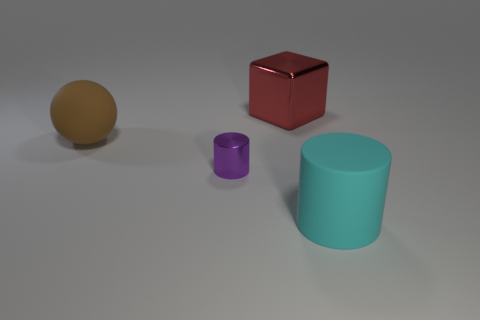Is there any other thing that is made of the same material as the block?
Your answer should be compact. Yes. What is the size of the rubber object that is to the left of the large rubber object in front of the big brown ball?
Provide a succinct answer. Large. Is the number of purple objects that are to the right of the cyan rubber cylinder the same as the number of tiny gray metal cylinders?
Make the answer very short. Yes. How many other things are the same color as the matte cylinder?
Your answer should be very brief. 0. Are there fewer big shiny cubes in front of the cube than cyan matte cylinders?
Make the answer very short. Yes. Are there any things that have the same size as the red shiny block?
Your answer should be compact. Yes. There is a big metal object; is its color the same as the large thing right of the red cube?
Ensure brevity in your answer.  No. There is a object that is on the right side of the red object; how many large things are in front of it?
Ensure brevity in your answer.  0. What color is the large matte object to the left of the large thing behind the large rubber ball?
Provide a succinct answer. Brown. What material is the thing that is both on the right side of the tiny purple shiny cylinder and in front of the big brown rubber ball?
Ensure brevity in your answer.  Rubber. 